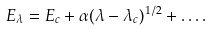Convert formula to latex. <formula><loc_0><loc_0><loc_500><loc_500>E _ { \lambda } = E _ { c } + \alpha ( \lambda - \lambda _ { c } ) ^ { 1 / 2 } + \dots .</formula> 